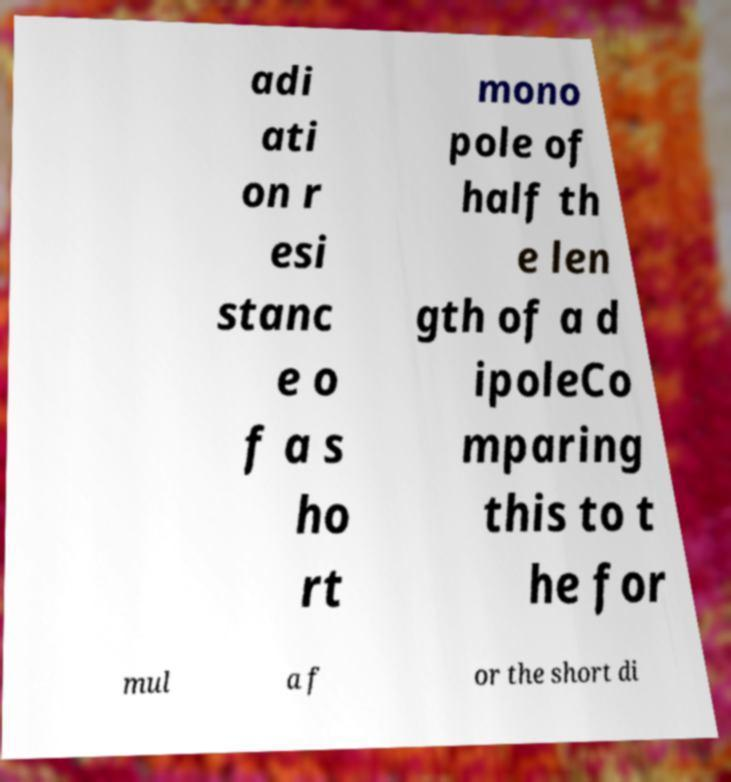Could you assist in decoding the text presented in this image and type it out clearly? adi ati on r esi stanc e o f a s ho rt mono pole of half th e len gth of a d ipoleCo mparing this to t he for mul a f or the short di 